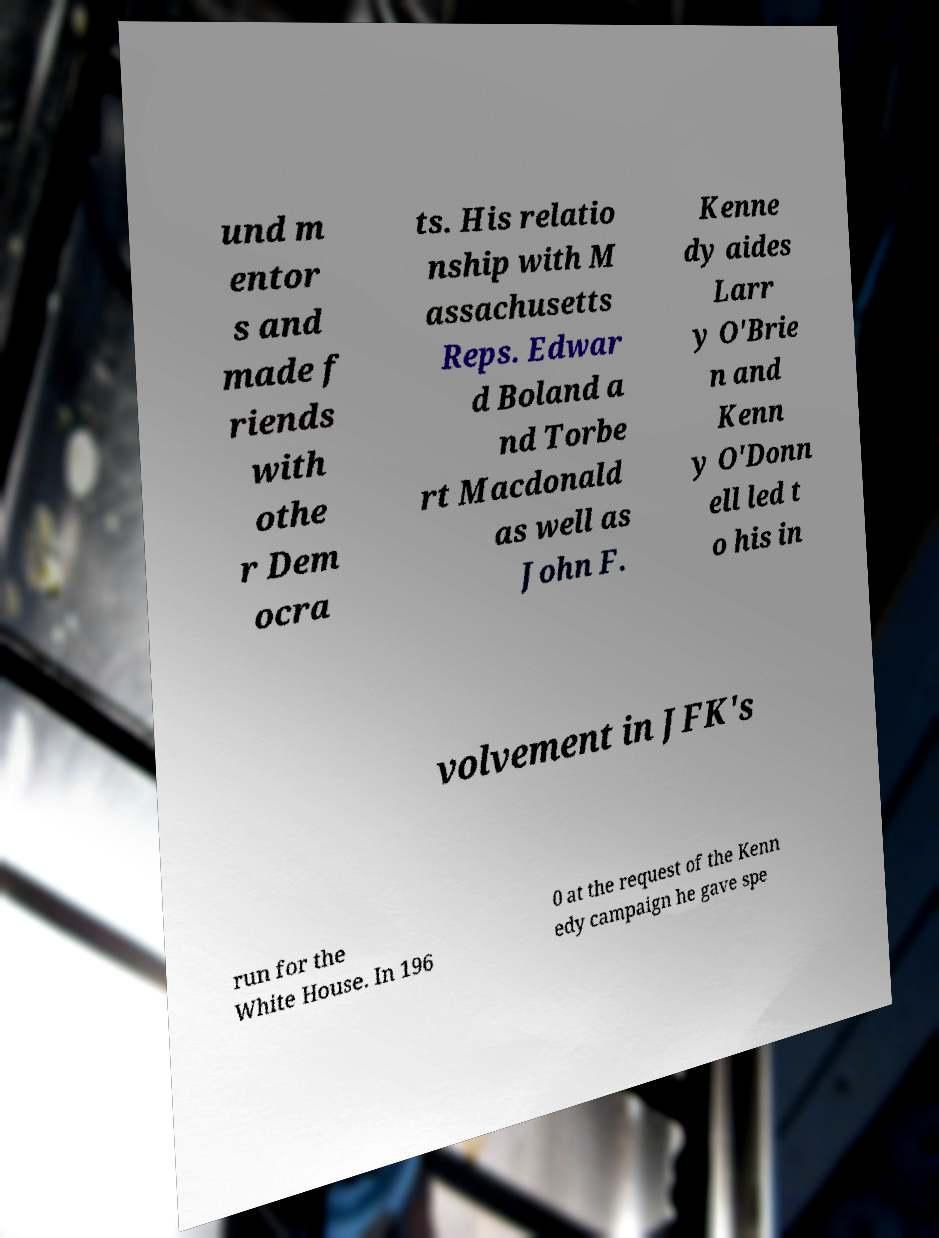Could you assist in decoding the text presented in this image and type it out clearly? und m entor s and made f riends with othe r Dem ocra ts. His relatio nship with M assachusetts Reps. Edwar d Boland a nd Torbe rt Macdonald as well as John F. Kenne dy aides Larr y O'Brie n and Kenn y O'Donn ell led t o his in volvement in JFK's run for the White House. In 196 0 at the request of the Kenn edy campaign he gave spe 